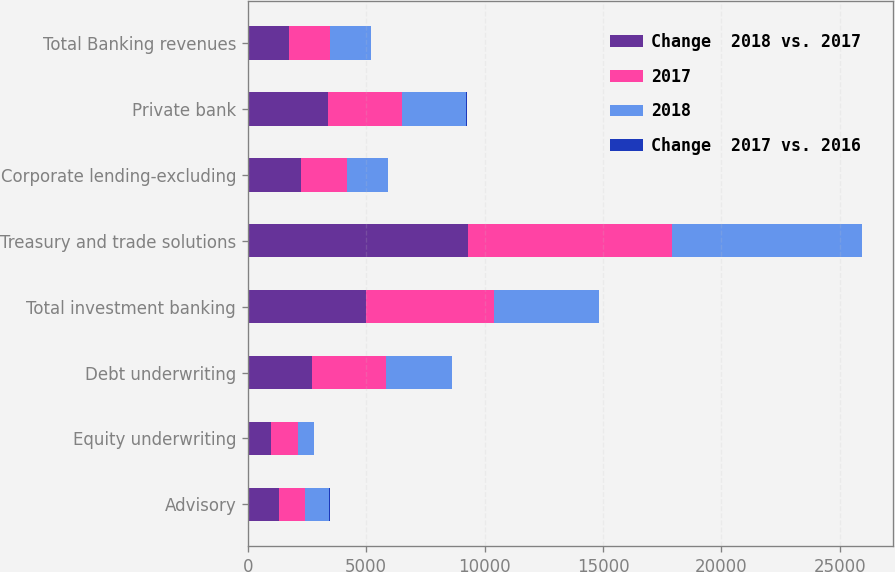Convert chart to OTSL. <chart><loc_0><loc_0><loc_500><loc_500><stacked_bar_chart><ecel><fcel>Advisory<fcel>Equity underwriting<fcel>Debt underwriting<fcel>Total investment banking<fcel>Treasury and trade solutions<fcel>Corporate lending-excluding<fcel>Private bank<fcel>Total Banking revenues<nl><fcel>Change  2018 vs. 2017<fcel>1301<fcel>991<fcel>2719<fcel>5011<fcel>9289<fcel>2232<fcel>3398<fcel>1734<nl><fcel>2017<fcel>1123<fcel>1121<fcel>3126<fcel>5370<fcel>8635<fcel>1938<fcel>3108<fcel>1734<nl><fcel>2018<fcel>1013<fcel>663<fcel>2776<fcel>4452<fcel>8022<fcel>1734<fcel>2728<fcel>1734<nl><fcel>Change  2017 vs. 2016<fcel>16<fcel>12<fcel>13<fcel>7<fcel>8<fcel>15<fcel>9<fcel>5<nl></chart> 